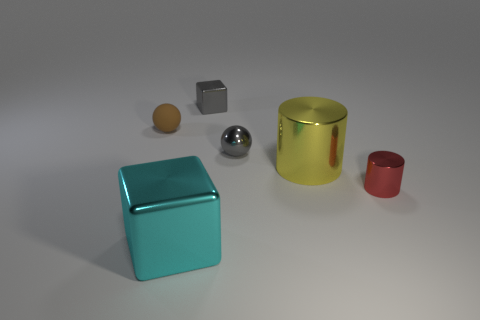Add 2 big cyan blocks. How many objects exist? 8 Subtract all red cylinders. How many cylinders are left? 1 Subtract 0 blue cubes. How many objects are left? 6 Subtract all balls. How many objects are left? 4 Subtract 1 blocks. How many blocks are left? 1 Subtract all gray cubes. Subtract all yellow spheres. How many cubes are left? 1 Subtract all blue balls. How many red blocks are left? 0 Subtract all small brown matte objects. Subtract all shiny cubes. How many objects are left? 3 Add 3 tiny red metal cylinders. How many tiny red metal cylinders are left? 4 Add 1 tiny metal spheres. How many tiny metal spheres exist? 2 